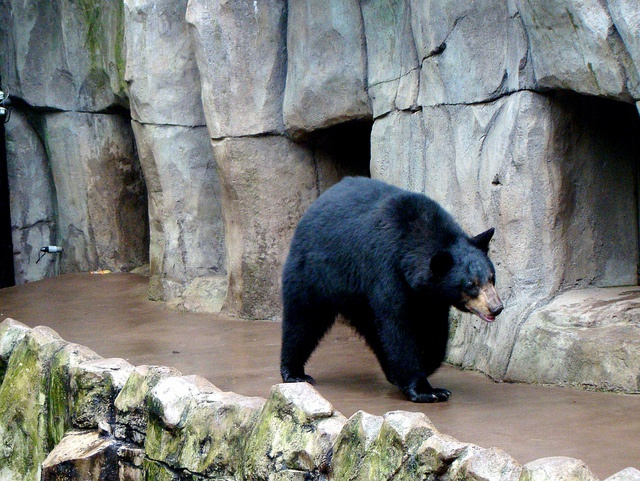Describe the objects in this image and their specific colors. I can see a bear in black, navy, blue, and gray tones in this image. 